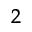<formula> <loc_0><loc_0><loc_500><loc_500>^ { 2 }</formula> 